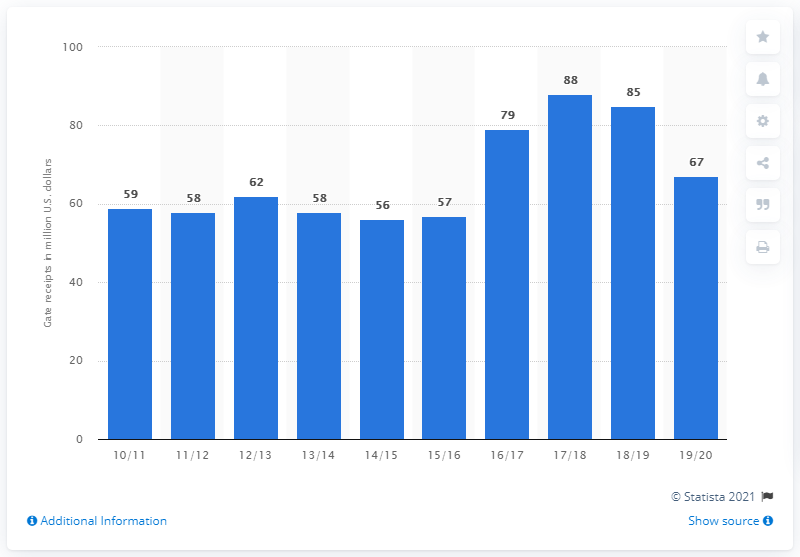Outline some significant characteristics in this image. The Boston Celtics generated $67 million in gate receipts during the 2019/20 season. There have been at least 5 years in which receipts have increased by more than 60%. The average between 2017/18 and 2018/19 is 86.5. 